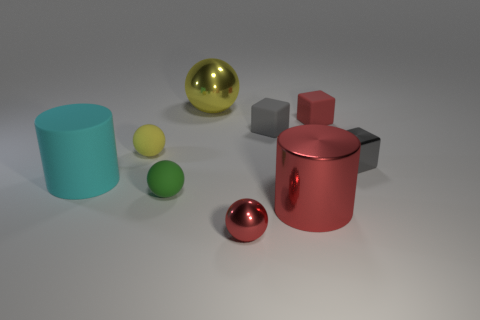Subtract all green balls. How many balls are left? 3 Add 1 gray matte blocks. How many objects exist? 10 Subtract all balls. How many objects are left? 5 Subtract all red cubes. How many cubes are left? 2 Subtract all purple blocks. How many yellow spheres are left? 2 Subtract all purple cylinders. Subtract all blue cubes. How many cylinders are left? 2 Subtract 1 red cylinders. How many objects are left? 8 Subtract 2 spheres. How many spheres are left? 2 Subtract all big red cylinders. Subtract all big shiny objects. How many objects are left? 6 Add 6 small gray shiny cubes. How many small gray shiny cubes are left? 7 